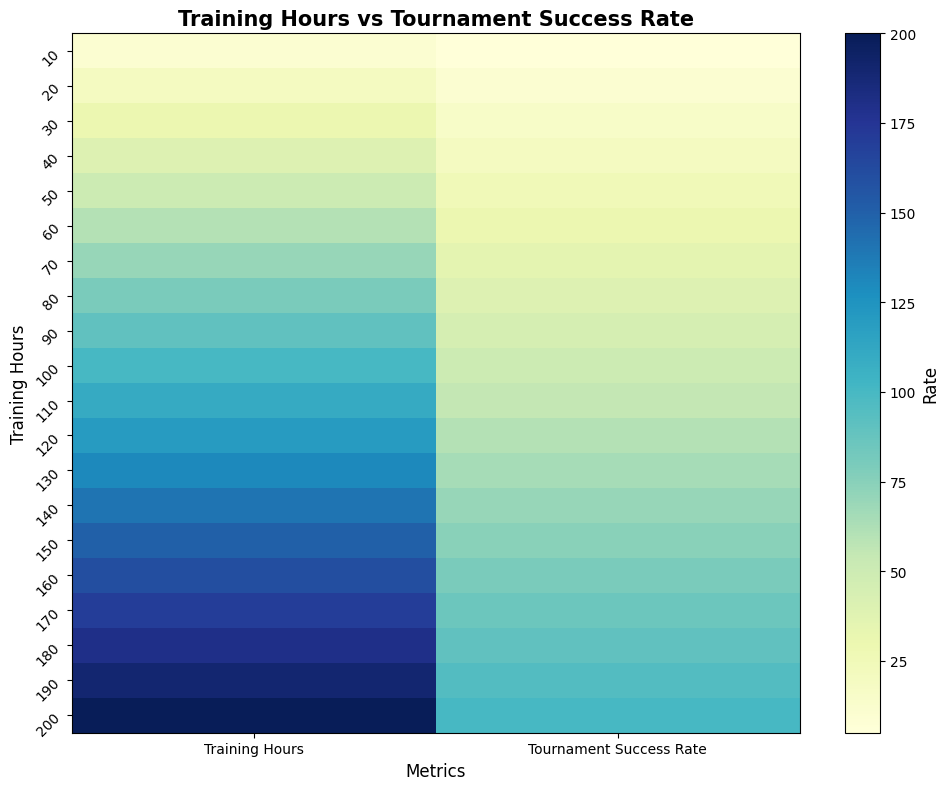What's the relationship between training hours and tournament success rate? The heatmap shows a linear increasing trend, where higher training hours correspond to higher success rates in tournaments.
Answer: Linear positive relationship How many training hours correspond to a 70% tournament success rate? By looking at the y-axis, we find that a 70% success rate is in line with 140 training hours.
Answer: 140 hours What is the difference in tournament success rate between 50 training hours and 150 training hours? The success rate at 50 training hours is 25%, and at 150 training hours, it is 75%. The difference is 75% - 25% = 50%.
Answer: 50% Does 100 training hours correspond to a higher success rate than 90 training hours? Yes, according to the heatmap, at 100 training hours, the success rate is 50%, compared to 45% at 90 training hours.
Answer: Yes What are the tournament success rates shown at intervals of 60 training hours? At 60 hours, 30%; at 120 hours, 60%; at 180 hours, 90%.
Answer: 30%, 60%, 90% Which row in the heatmap shows a transition from lower to higher success rates as you go from left to right? The entire image does, as each row represents higher training hours leading to higher success rates from left to right.
Answer: Every row By how much does the success rate increase when training hours go from 40 to 80? At 40 training hours, the success rate is 20%; at 80 hours, it's 40%. The increase is 40% - 20% = 20%.
Answer: 20% Which training hour level is colored most intensely for tournament success rate? The most intense color, indicating the highest success rate of 100%, corresponds to 200 training hours.
Answer: 200 hours What's the range of training hours represented in the heatmap? The y-axis shows training hours from 10 to 200.
Answer: 10 to 200 Does the heatmap suggest that doubling training hours could lead to doubling success rate? Yes, the linear trend in the heatmap shows that doubling training hours approximately doubles the success rate.
Answer: Yes 